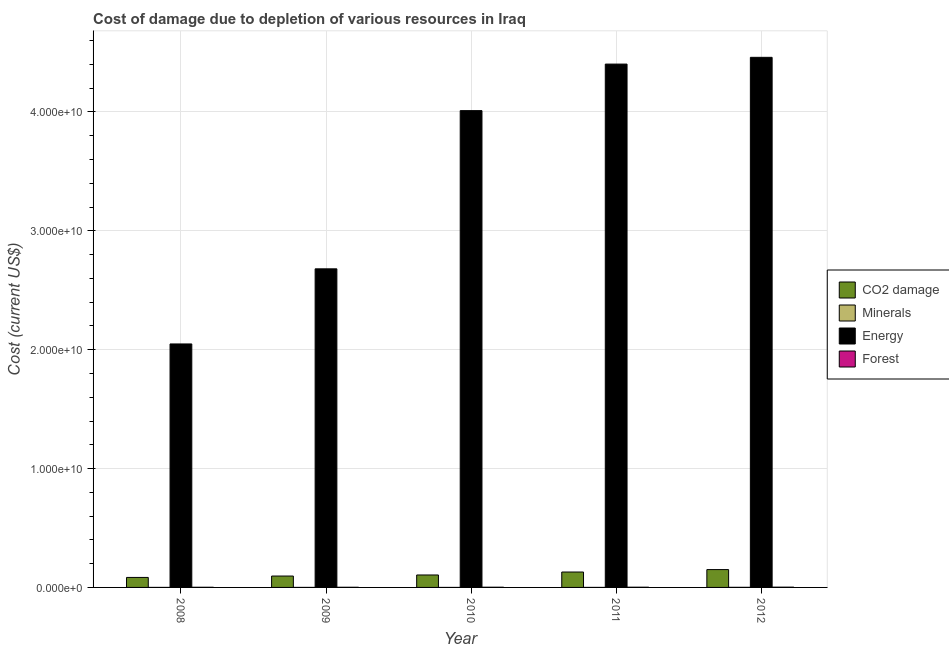How many groups of bars are there?
Make the answer very short. 5. Are the number of bars per tick equal to the number of legend labels?
Make the answer very short. Yes. How many bars are there on the 1st tick from the right?
Offer a terse response. 4. In how many cases, is the number of bars for a given year not equal to the number of legend labels?
Offer a terse response. 0. What is the cost of damage due to depletion of minerals in 2012?
Give a very brief answer. 8.17e+06. Across all years, what is the maximum cost of damage due to depletion of minerals?
Provide a short and direct response. 8.17e+06. Across all years, what is the minimum cost of damage due to depletion of forests?
Offer a very short reply. 1.26e+07. In which year was the cost of damage due to depletion of minerals minimum?
Provide a succinct answer. 2010. What is the total cost of damage due to depletion of forests in the graph?
Your response must be concise. 8.13e+07. What is the difference between the cost of damage due to depletion of minerals in 2008 and that in 2010?
Offer a terse response. 9.83e+05. What is the difference between the cost of damage due to depletion of forests in 2009 and the cost of damage due to depletion of energy in 2011?
Offer a very short reply. -5.12e+06. What is the average cost of damage due to depletion of coal per year?
Offer a terse response. 1.13e+09. What is the ratio of the cost of damage due to depletion of forests in 2008 to that in 2011?
Provide a short and direct response. 0.72. Is the cost of damage due to depletion of forests in 2009 less than that in 2010?
Your answer should be very brief. Yes. Is the difference between the cost of damage due to depletion of coal in 2010 and 2012 greater than the difference between the cost of damage due to depletion of energy in 2010 and 2012?
Your response must be concise. No. What is the difference between the highest and the second highest cost of damage due to depletion of coal?
Your answer should be very brief. 2.05e+08. What is the difference between the highest and the lowest cost of damage due to depletion of coal?
Offer a terse response. 6.60e+08. What does the 1st bar from the left in 2009 represents?
Your answer should be compact. CO2 damage. What does the 2nd bar from the right in 2009 represents?
Provide a short and direct response. Energy. Are all the bars in the graph horizontal?
Your answer should be compact. No. How many years are there in the graph?
Provide a short and direct response. 5. Does the graph contain grids?
Give a very brief answer. Yes. Where does the legend appear in the graph?
Ensure brevity in your answer.  Center right. How are the legend labels stacked?
Offer a very short reply. Vertical. What is the title of the graph?
Provide a succinct answer. Cost of damage due to depletion of various resources in Iraq . What is the label or title of the X-axis?
Provide a succinct answer. Year. What is the label or title of the Y-axis?
Your response must be concise. Cost (current US$). What is the Cost (current US$) of CO2 damage in 2008?
Give a very brief answer. 8.41e+08. What is the Cost (current US$) of Minerals in 2008?
Provide a succinct answer. 1.14e+06. What is the Cost (current US$) in Energy in 2008?
Your response must be concise. 2.05e+1. What is the Cost (current US$) of Forest in 2008?
Provide a succinct answer. 1.28e+07. What is the Cost (current US$) of CO2 damage in 2009?
Provide a succinct answer. 9.58e+08. What is the Cost (current US$) of Minerals in 2009?
Ensure brevity in your answer.  4.96e+05. What is the Cost (current US$) of Energy in 2009?
Offer a very short reply. 2.68e+1. What is the Cost (current US$) in Forest in 2009?
Your answer should be very brief. 1.26e+07. What is the Cost (current US$) in CO2 damage in 2010?
Give a very brief answer. 1.05e+09. What is the Cost (current US$) of Minerals in 2010?
Offer a terse response. 1.57e+05. What is the Cost (current US$) in Energy in 2010?
Ensure brevity in your answer.  4.01e+1. What is the Cost (current US$) in Forest in 2010?
Ensure brevity in your answer.  1.62e+07. What is the Cost (current US$) in CO2 damage in 2011?
Your response must be concise. 1.30e+09. What is the Cost (current US$) of Minerals in 2011?
Make the answer very short. 1.20e+06. What is the Cost (current US$) of Energy in 2011?
Offer a terse response. 4.40e+1. What is the Cost (current US$) of Forest in 2011?
Make the answer very short. 1.77e+07. What is the Cost (current US$) in CO2 damage in 2012?
Offer a terse response. 1.50e+09. What is the Cost (current US$) in Minerals in 2012?
Keep it short and to the point. 8.17e+06. What is the Cost (current US$) in Energy in 2012?
Your answer should be very brief. 4.46e+1. What is the Cost (current US$) in Forest in 2012?
Make the answer very short. 2.20e+07. Across all years, what is the maximum Cost (current US$) of CO2 damage?
Provide a short and direct response. 1.50e+09. Across all years, what is the maximum Cost (current US$) in Minerals?
Your answer should be compact. 8.17e+06. Across all years, what is the maximum Cost (current US$) in Energy?
Ensure brevity in your answer.  4.46e+1. Across all years, what is the maximum Cost (current US$) in Forest?
Ensure brevity in your answer.  2.20e+07. Across all years, what is the minimum Cost (current US$) of CO2 damage?
Offer a terse response. 8.41e+08. Across all years, what is the minimum Cost (current US$) in Minerals?
Offer a terse response. 1.57e+05. Across all years, what is the minimum Cost (current US$) of Energy?
Offer a very short reply. 2.05e+1. Across all years, what is the minimum Cost (current US$) of Forest?
Your answer should be compact. 1.26e+07. What is the total Cost (current US$) in CO2 damage in the graph?
Your answer should be compact. 5.64e+09. What is the total Cost (current US$) in Minerals in the graph?
Keep it short and to the point. 1.12e+07. What is the total Cost (current US$) of Energy in the graph?
Ensure brevity in your answer.  1.76e+11. What is the total Cost (current US$) of Forest in the graph?
Ensure brevity in your answer.  8.13e+07. What is the difference between the Cost (current US$) in CO2 damage in 2008 and that in 2009?
Your answer should be very brief. -1.18e+08. What is the difference between the Cost (current US$) of Minerals in 2008 and that in 2009?
Your answer should be compact. 6.45e+05. What is the difference between the Cost (current US$) in Energy in 2008 and that in 2009?
Your response must be concise. -6.32e+09. What is the difference between the Cost (current US$) in Forest in 2008 and that in 2009?
Ensure brevity in your answer.  2.27e+05. What is the difference between the Cost (current US$) of CO2 damage in 2008 and that in 2010?
Make the answer very short. -2.07e+08. What is the difference between the Cost (current US$) in Minerals in 2008 and that in 2010?
Your answer should be very brief. 9.83e+05. What is the difference between the Cost (current US$) in Energy in 2008 and that in 2010?
Your answer should be compact. -1.96e+1. What is the difference between the Cost (current US$) of Forest in 2008 and that in 2010?
Your answer should be very brief. -3.43e+06. What is the difference between the Cost (current US$) in CO2 damage in 2008 and that in 2011?
Offer a terse response. -4.55e+08. What is the difference between the Cost (current US$) in Minerals in 2008 and that in 2011?
Provide a succinct answer. -5.56e+04. What is the difference between the Cost (current US$) of Energy in 2008 and that in 2011?
Your answer should be very brief. -2.35e+1. What is the difference between the Cost (current US$) of Forest in 2008 and that in 2011?
Give a very brief answer. -4.89e+06. What is the difference between the Cost (current US$) in CO2 damage in 2008 and that in 2012?
Keep it short and to the point. -6.60e+08. What is the difference between the Cost (current US$) of Minerals in 2008 and that in 2012?
Provide a short and direct response. -7.03e+06. What is the difference between the Cost (current US$) of Energy in 2008 and that in 2012?
Keep it short and to the point. -2.41e+1. What is the difference between the Cost (current US$) of Forest in 2008 and that in 2012?
Offer a very short reply. -9.24e+06. What is the difference between the Cost (current US$) of CO2 damage in 2009 and that in 2010?
Your answer should be compact. -8.91e+07. What is the difference between the Cost (current US$) in Minerals in 2009 and that in 2010?
Offer a terse response. 3.38e+05. What is the difference between the Cost (current US$) of Energy in 2009 and that in 2010?
Keep it short and to the point. -1.33e+1. What is the difference between the Cost (current US$) in Forest in 2009 and that in 2010?
Your answer should be very brief. -3.66e+06. What is the difference between the Cost (current US$) of CO2 damage in 2009 and that in 2011?
Keep it short and to the point. -3.37e+08. What is the difference between the Cost (current US$) of Minerals in 2009 and that in 2011?
Offer a terse response. -7.01e+05. What is the difference between the Cost (current US$) in Energy in 2009 and that in 2011?
Your response must be concise. -1.72e+1. What is the difference between the Cost (current US$) in Forest in 2009 and that in 2011?
Provide a succinct answer. -5.12e+06. What is the difference between the Cost (current US$) of CO2 damage in 2009 and that in 2012?
Keep it short and to the point. -5.42e+08. What is the difference between the Cost (current US$) in Minerals in 2009 and that in 2012?
Give a very brief answer. -7.67e+06. What is the difference between the Cost (current US$) of Energy in 2009 and that in 2012?
Provide a short and direct response. -1.78e+1. What is the difference between the Cost (current US$) of Forest in 2009 and that in 2012?
Offer a terse response. -9.47e+06. What is the difference between the Cost (current US$) in CO2 damage in 2010 and that in 2011?
Your answer should be compact. -2.48e+08. What is the difference between the Cost (current US$) of Minerals in 2010 and that in 2011?
Offer a very short reply. -1.04e+06. What is the difference between the Cost (current US$) of Energy in 2010 and that in 2011?
Make the answer very short. -3.92e+09. What is the difference between the Cost (current US$) of Forest in 2010 and that in 2011?
Ensure brevity in your answer.  -1.46e+06. What is the difference between the Cost (current US$) in CO2 damage in 2010 and that in 2012?
Your answer should be very brief. -4.53e+08. What is the difference between the Cost (current US$) of Minerals in 2010 and that in 2012?
Give a very brief answer. -8.01e+06. What is the difference between the Cost (current US$) in Energy in 2010 and that in 2012?
Keep it short and to the point. -4.48e+09. What is the difference between the Cost (current US$) in Forest in 2010 and that in 2012?
Give a very brief answer. -5.81e+06. What is the difference between the Cost (current US$) of CO2 damage in 2011 and that in 2012?
Make the answer very short. -2.05e+08. What is the difference between the Cost (current US$) in Minerals in 2011 and that in 2012?
Keep it short and to the point. -6.97e+06. What is the difference between the Cost (current US$) in Energy in 2011 and that in 2012?
Your answer should be compact. -5.68e+08. What is the difference between the Cost (current US$) in Forest in 2011 and that in 2012?
Keep it short and to the point. -4.35e+06. What is the difference between the Cost (current US$) of CO2 damage in 2008 and the Cost (current US$) of Minerals in 2009?
Your response must be concise. 8.40e+08. What is the difference between the Cost (current US$) of CO2 damage in 2008 and the Cost (current US$) of Energy in 2009?
Offer a terse response. -2.60e+1. What is the difference between the Cost (current US$) in CO2 damage in 2008 and the Cost (current US$) in Forest in 2009?
Keep it short and to the point. 8.28e+08. What is the difference between the Cost (current US$) in Minerals in 2008 and the Cost (current US$) in Energy in 2009?
Your answer should be very brief. -2.68e+1. What is the difference between the Cost (current US$) in Minerals in 2008 and the Cost (current US$) in Forest in 2009?
Provide a succinct answer. -1.14e+07. What is the difference between the Cost (current US$) of Energy in 2008 and the Cost (current US$) of Forest in 2009?
Make the answer very short. 2.05e+1. What is the difference between the Cost (current US$) of CO2 damage in 2008 and the Cost (current US$) of Minerals in 2010?
Provide a short and direct response. 8.40e+08. What is the difference between the Cost (current US$) in CO2 damage in 2008 and the Cost (current US$) in Energy in 2010?
Make the answer very short. -3.93e+1. What is the difference between the Cost (current US$) of CO2 damage in 2008 and the Cost (current US$) of Forest in 2010?
Keep it short and to the point. 8.24e+08. What is the difference between the Cost (current US$) of Minerals in 2008 and the Cost (current US$) of Energy in 2010?
Your answer should be compact. -4.01e+1. What is the difference between the Cost (current US$) in Minerals in 2008 and the Cost (current US$) in Forest in 2010?
Ensure brevity in your answer.  -1.51e+07. What is the difference between the Cost (current US$) of Energy in 2008 and the Cost (current US$) of Forest in 2010?
Your answer should be compact. 2.05e+1. What is the difference between the Cost (current US$) in CO2 damage in 2008 and the Cost (current US$) in Minerals in 2011?
Your response must be concise. 8.39e+08. What is the difference between the Cost (current US$) in CO2 damage in 2008 and the Cost (current US$) in Energy in 2011?
Your answer should be compact. -4.32e+1. What is the difference between the Cost (current US$) in CO2 damage in 2008 and the Cost (current US$) in Forest in 2011?
Your response must be concise. 8.23e+08. What is the difference between the Cost (current US$) in Minerals in 2008 and the Cost (current US$) in Energy in 2011?
Offer a terse response. -4.40e+1. What is the difference between the Cost (current US$) of Minerals in 2008 and the Cost (current US$) of Forest in 2011?
Your answer should be compact. -1.65e+07. What is the difference between the Cost (current US$) in Energy in 2008 and the Cost (current US$) in Forest in 2011?
Provide a succinct answer. 2.05e+1. What is the difference between the Cost (current US$) in CO2 damage in 2008 and the Cost (current US$) in Minerals in 2012?
Ensure brevity in your answer.  8.32e+08. What is the difference between the Cost (current US$) in CO2 damage in 2008 and the Cost (current US$) in Energy in 2012?
Make the answer very short. -4.38e+1. What is the difference between the Cost (current US$) in CO2 damage in 2008 and the Cost (current US$) in Forest in 2012?
Ensure brevity in your answer.  8.19e+08. What is the difference between the Cost (current US$) in Minerals in 2008 and the Cost (current US$) in Energy in 2012?
Provide a succinct answer. -4.46e+1. What is the difference between the Cost (current US$) of Minerals in 2008 and the Cost (current US$) of Forest in 2012?
Your answer should be very brief. -2.09e+07. What is the difference between the Cost (current US$) of Energy in 2008 and the Cost (current US$) of Forest in 2012?
Your answer should be compact. 2.05e+1. What is the difference between the Cost (current US$) of CO2 damage in 2009 and the Cost (current US$) of Minerals in 2010?
Your answer should be very brief. 9.58e+08. What is the difference between the Cost (current US$) of CO2 damage in 2009 and the Cost (current US$) of Energy in 2010?
Your answer should be compact. -3.92e+1. What is the difference between the Cost (current US$) in CO2 damage in 2009 and the Cost (current US$) in Forest in 2010?
Ensure brevity in your answer.  9.42e+08. What is the difference between the Cost (current US$) in Minerals in 2009 and the Cost (current US$) in Energy in 2010?
Provide a succinct answer. -4.01e+1. What is the difference between the Cost (current US$) of Minerals in 2009 and the Cost (current US$) of Forest in 2010?
Your response must be concise. -1.57e+07. What is the difference between the Cost (current US$) in Energy in 2009 and the Cost (current US$) in Forest in 2010?
Offer a very short reply. 2.68e+1. What is the difference between the Cost (current US$) of CO2 damage in 2009 and the Cost (current US$) of Minerals in 2011?
Ensure brevity in your answer.  9.57e+08. What is the difference between the Cost (current US$) of CO2 damage in 2009 and the Cost (current US$) of Energy in 2011?
Provide a short and direct response. -4.31e+1. What is the difference between the Cost (current US$) of CO2 damage in 2009 and the Cost (current US$) of Forest in 2011?
Offer a very short reply. 9.41e+08. What is the difference between the Cost (current US$) in Minerals in 2009 and the Cost (current US$) in Energy in 2011?
Offer a terse response. -4.40e+1. What is the difference between the Cost (current US$) in Minerals in 2009 and the Cost (current US$) in Forest in 2011?
Your answer should be very brief. -1.72e+07. What is the difference between the Cost (current US$) of Energy in 2009 and the Cost (current US$) of Forest in 2011?
Your answer should be compact. 2.68e+1. What is the difference between the Cost (current US$) of CO2 damage in 2009 and the Cost (current US$) of Minerals in 2012?
Provide a succinct answer. 9.50e+08. What is the difference between the Cost (current US$) in CO2 damage in 2009 and the Cost (current US$) in Energy in 2012?
Your answer should be very brief. -4.36e+1. What is the difference between the Cost (current US$) of CO2 damage in 2009 and the Cost (current US$) of Forest in 2012?
Your answer should be very brief. 9.36e+08. What is the difference between the Cost (current US$) in Minerals in 2009 and the Cost (current US$) in Energy in 2012?
Provide a succinct answer. -4.46e+1. What is the difference between the Cost (current US$) of Minerals in 2009 and the Cost (current US$) of Forest in 2012?
Keep it short and to the point. -2.15e+07. What is the difference between the Cost (current US$) in Energy in 2009 and the Cost (current US$) in Forest in 2012?
Keep it short and to the point. 2.68e+1. What is the difference between the Cost (current US$) of CO2 damage in 2010 and the Cost (current US$) of Minerals in 2011?
Ensure brevity in your answer.  1.05e+09. What is the difference between the Cost (current US$) of CO2 damage in 2010 and the Cost (current US$) of Energy in 2011?
Offer a very short reply. -4.30e+1. What is the difference between the Cost (current US$) of CO2 damage in 2010 and the Cost (current US$) of Forest in 2011?
Keep it short and to the point. 1.03e+09. What is the difference between the Cost (current US$) of Minerals in 2010 and the Cost (current US$) of Energy in 2011?
Ensure brevity in your answer.  -4.40e+1. What is the difference between the Cost (current US$) in Minerals in 2010 and the Cost (current US$) in Forest in 2011?
Provide a succinct answer. -1.75e+07. What is the difference between the Cost (current US$) in Energy in 2010 and the Cost (current US$) in Forest in 2011?
Provide a succinct answer. 4.01e+1. What is the difference between the Cost (current US$) in CO2 damage in 2010 and the Cost (current US$) in Minerals in 2012?
Offer a very short reply. 1.04e+09. What is the difference between the Cost (current US$) in CO2 damage in 2010 and the Cost (current US$) in Energy in 2012?
Offer a very short reply. -4.36e+1. What is the difference between the Cost (current US$) in CO2 damage in 2010 and the Cost (current US$) in Forest in 2012?
Your answer should be compact. 1.03e+09. What is the difference between the Cost (current US$) of Minerals in 2010 and the Cost (current US$) of Energy in 2012?
Give a very brief answer. -4.46e+1. What is the difference between the Cost (current US$) in Minerals in 2010 and the Cost (current US$) in Forest in 2012?
Give a very brief answer. -2.19e+07. What is the difference between the Cost (current US$) of Energy in 2010 and the Cost (current US$) of Forest in 2012?
Make the answer very short. 4.01e+1. What is the difference between the Cost (current US$) in CO2 damage in 2011 and the Cost (current US$) in Minerals in 2012?
Offer a very short reply. 1.29e+09. What is the difference between the Cost (current US$) of CO2 damage in 2011 and the Cost (current US$) of Energy in 2012?
Give a very brief answer. -4.33e+1. What is the difference between the Cost (current US$) of CO2 damage in 2011 and the Cost (current US$) of Forest in 2012?
Give a very brief answer. 1.27e+09. What is the difference between the Cost (current US$) in Minerals in 2011 and the Cost (current US$) in Energy in 2012?
Provide a succinct answer. -4.46e+1. What is the difference between the Cost (current US$) of Minerals in 2011 and the Cost (current US$) of Forest in 2012?
Your answer should be very brief. -2.08e+07. What is the difference between the Cost (current US$) in Energy in 2011 and the Cost (current US$) in Forest in 2012?
Offer a terse response. 4.40e+1. What is the average Cost (current US$) of CO2 damage per year?
Offer a very short reply. 1.13e+09. What is the average Cost (current US$) in Minerals per year?
Your answer should be compact. 2.23e+06. What is the average Cost (current US$) in Energy per year?
Provide a short and direct response. 3.52e+1. What is the average Cost (current US$) of Forest per year?
Ensure brevity in your answer.  1.63e+07. In the year 2008, what is the difference between the Cost (current US$) in CO2 damage and Cost (current US$) in Minerals?
Provide a short and direct response. 8.39e+08. In the year 2008, what is the difference between the Cost (current US$) in CO2 damage and Cost (current US$) in Energy?
Keep it short and to the point. -1.96e+1. In the year 2008, what is the difference between the Cost (current US$) of CO2 damage and Cost (current US$) of Forest?
Your answer should be very brief. 8.28e+08. In the year 2008, what is the difference between the Cost (current US$) of Minerals and Cost (current US$) of Energy?
Your response must be concise. -2.05e+1. In the year 2008, what is the difference between the Cost (current US$) in Minerals and Cost (current US$) in Forest?
Make the answer very short. -1.17e+07. In the year 2008, what is the difference between the Cost (current US$) of Energy and Cost (current US$) of Forest?
Ensure brevity in your answer.  2.05e+1. In the year 2009, what is the difference between the Cost (current US$) in CO2 damage and Cost (current US$) in Minerals?
Offer a very short reply. 9.58e+08. In the year 2009, what is the difference between the Cost (current US$) in CO2 damage and Cost (current US$) in Energy?
Provide a short and direct response. -2.58e+1. In the year 2009, what is the difference between the Cost (current US$) of CO2 damage and Cost (current US$) of Forest?
Your answer should be very brief. 9.46e+08. In the year 2009, what is the difference between the Cost (current US$) in Minerals and Cost (current US$) in Energy?
Ensure brevity in your answer.  -2.68e+1. In the year 2009, what is the difference between the Cost (current US$) of Minerals and Cost (current US$) of Forest?
Offer a terse response. -1.21e+07. In the year 2009, what is the difference between the Cost (current US$) of Energy and Cost (current US$) of Forest?
Offer a terse response. 2.68e+1. In the year 2010, what is the difference between the Cost (current US$) in CO2 damage and Cost (current US$) in Minerals?
Make the answer very short. 1.05e+09. In the year 2010, what is the difference between the Cost (current US$) of CO2 damage and Cost (current US$) of Energy?
Provide a short and direct response. -3.91e+1. In the year 2010, what is the difference between the Cost (current US$) of CO2 damage and Cost (current US$) of Forest?
Provide a short and direct response. 1.03e+09. In the year 2010, what is the difference between the Cost (current US$) in Minerals and Cost (current US$) in Energy?
Offer a very short reply. -4.01e+1. In the year 2010, what is the difference between the Cost (current US$) in Minerals and Cost (current US$) in Forest?
Provide a succinct answer. -1.61e+07. In the year 2010, what is the difference between the Cost (current US$) in Energy and Cost (current US$) in Forest?
Your response must be concise. 4.01e+1. In the year 2011, what is the difference between the Cost (current US$) of CO2 damage and Cost (current US$) of Minerals?
Make the answer very short. 1.29e+09. In the year 2011, what is the difference between the Cost (current US$) in CO2 damage and Cost (current US$) in Energy?
Your answer should be compact. -4.27e+1. In the year 2011, what is the difference between the Cost (current US$) in CO2 damage and Cost (current US$) in Forest?
Your answer should be very brief. 1.28e+09. In the year 2011, what is the difference between the Cost (current US$) in Minerals and Cost (current US$) in Energy?
Offer a very short reply. -4.40e+1. In the year 2011, what is the difference between the Cost (current US$) of Minerals and Cost (current US$) of Forest?
Provide a succinct answer. -1.65e+07. In the year 2011, what is the difference between the Cost (current US$) of Energy and Cost (current US$) of Forest?
Keep it short and to the point. 4.40e+1. In the year 2012, what is the difference between the Cost (current US$) of CO2 damage and Cost (current US$) of Minerals?
Make the answer very short. 1.49e+09. In the year 2012, what is the difference between the Cost (current US$) of CO2 damage and Cost (current US$) of Energy?
Offer a terse response. -4.31e+1. In the year 2012, what is the difference between the Cost (current US$) in CO2 damage and Cost (current US$) in Forest?
Offer a very short reply. 1.48e+09. In the year 2012, what is the difference between the Cost (current US$) of Minerals and Cost (current US$) of Energy?
Offer a terse response. -4.46e+1. In the year 2012, what is the difference between the Cost (current US$) in Minerals and Cost (current US$) in Forest?
Offer a terse response. -1.39e+07. In the year 2012, what is the difference between the Cost (current US$) in Energy and Cost (current US$) in Forest?
Your response must be concise. 4.46e+1. What is the ratio of the Cost (current US$) of CO2 damage in 2008 to that in 2009?
Provide a succinct answer. 0.88. What is the ratio of the Cost (current US$) in Minerals in 2008 to that in 2009?
Offer a terse response. 2.3. What is the ratio of the Cost (current US$) of Energy in 2008 to that in 2009?
Offer a terse response. 0.76. What is the ratio of the Cost (current US$) of Forest in 2008 to that in 2009?
Offer a terse response. 1.02. What is the ratio of the Cost (current US$) in CO2 damage in 2008 to that in 2010?
Make the answer very short. 0.8. What is the ratio of the Cost (current US$) in Minerals in 2008 to that in 2010?
Your answer should be very brief. 7.25. What is the ratio of the Cost (current US$) of Energy in 2008 to that in 2010?
Your response must be concise. 0.51. What is the ratio of the Cost (current US$) in Forest in 2008 to that in 2010?
Provide a short and direct response. 0.79. What is the ratio of the Cost (current US$) of CO2 damage in 2008 to that in 2011?
Offer a terse response. 0.65. What is the ratio of the Cost (current US$) of Minerals in 2008 to that in 2011?
Offer a terse response. 0.95. What is the ratio of the Cost (current US$) of Energy in 2008 to that in 2011?
Your response must be concise. 0.47. What is the ratio of the Cost (current US$) in Forest in 2008 to that in 2011?
Offer a terse response. 0.72. What is the ratio of the Cost (current US$) of CO2 damage in 2008 to that in 2012?
Make the answer very short. 0.56. What is the ratio of the Cost (current US$) of Minerals in 2008 to that in 2012?
Keep it short and to the point. 0.14. What is the ratio of the Cost (current US$) of Energy in 2008 to that in 2012?
Your response must be concise. 0.46. What is the ratio of the Cost (current US$) in Forest in 2008 to that in 2012?
Your response must be concise. 0.58. What is the ratio of the Cost (current US$) in CO2 damage in 2009 to that in 2010?
Offer a very short reply. 0.91. What is the ratio of the Cost (current US$) in Minerals in 2009 to that in 2010?
Ensure brevity in your answer.  3.15. What is the ratio of the Cost (current US$) of Energy in 2009 to that in 2010?
Provide a short and direct response. 0.67. What is the ratio of the Cost (current US$) of Forest in 2009 to that in 2010?
Offer a terse response. 0.77. What is the ratio of the Cost (current US$) of CO2 damage in 2009 to that in 2011?
Keep it short and to the point. 0.74. What is the ratio of the Cost (current US$) in Minerals in 2009 to that in 2011?
Offer a very short reply. 0.41. What is the ratio of the Cost (current US$) of Energy in 2009 to that in 2011?
Offer a terse response. 0.61. What is the ratio of the Cost (current US$) in Forest in 2009 to that in 2011?
Give a very brief answer. 0.71. What is the ratio of the Cost (current US$) in CO2 damage in 2009 to that in 2012?
Make the answer very short. 0.64. What is the ratio of the Cost (current US$) of Minerals in 2009 to that in 2012?
Keep it short and to the point. 0.06. What is the ratio of the Cost (current US$) of Energy in 2009 to that in 2012?
Offer a terse response. 0.6. What is the ratio of the Cost (current US$) of Forest in 2009 to that in 2012?
Offer a very short reply. 0.57. What is the ratio of the Cost (current US$) of CO2 damage in 2010 to that in 2011?
Offer a very short reply. 0.81. What is the ratio of the Cost (current US$) of Minerals in 2010 to that in 2011?
Make the answer very short. 0.13. What is the ratio of the Cost (current US$) in Energy in 2010 to that in 2011?
Make the answer very short. 0.91. What is the ratio of the Cost (current US$) of Forest in 2010 to that in 2011?
Offer a very short reply. 0.92. What is the ratio of the Cost (current US$) of CO2 damage in 2010 to that in 2012?
Your answer should be very brief. 0.7. What is the ratio of the Cost (current US$) in Minerals in 2010 to that in 2012?
Keep it short and to the point. 0.02. What is the ratio of the Cost (current US$) of Energy in 2010 to that in 2012?
Provide a succinct answer. 0.9. What is the ratio of the Cost (current US$) of Forest in 2010 to that in 2012?
Ensure brevity in your answer.  0.74. What is the ratio of the Cost (current US$) in CO2 damage in 2011 to that in 2012?
Your response must be concise. 0.86. What is the ratio of the Cost (current US$) of Minerals in 2011 to that in 2012?
Offer a terse response. 0.15. What is the ratio of the Cost (current US$) of Energy in 2011 to that in 2012?
Ensure brevity in your answer.  0.99. What is the ratio of the Cost (current US$) in Forest in 2011 to that in 2012?
Provide a short and direct response. 0.8. What is the difference between the highest and the second highest Cost (current US$) in CO2 damage?
Your answer should be very brief. 2.05e+08. What is the difference between the highest and the second highest Cost (current US$) of Minerals?
Provide a succinct answer. 6.97e+06. What is the difference between the highest and the second highest Cost (current US$) of Energy?
Your response must be concise. 5.68e+08. What is the difference between the highest and the second highest Cost (current US$) of Forest?
Keep it short and to the point. 4.35e+06. What is the difference between the highest and the lowest Cost (current US$) of CO2 damage?
Ensure brevity in your answer.  6.60e+08. What is the difference between the highest and the lowest Cost (current US$) of Minerals?
Make the answer very short. 8.01e+06. What is the difference between the highest and the lowest Cost (current US$) of Energy?
Keep it short and to the point. 2.41e+1. What is the difference between the highest and the lowest Cost (current US$) in Forest?
Provide a short and direct response. 9.47e+06. 